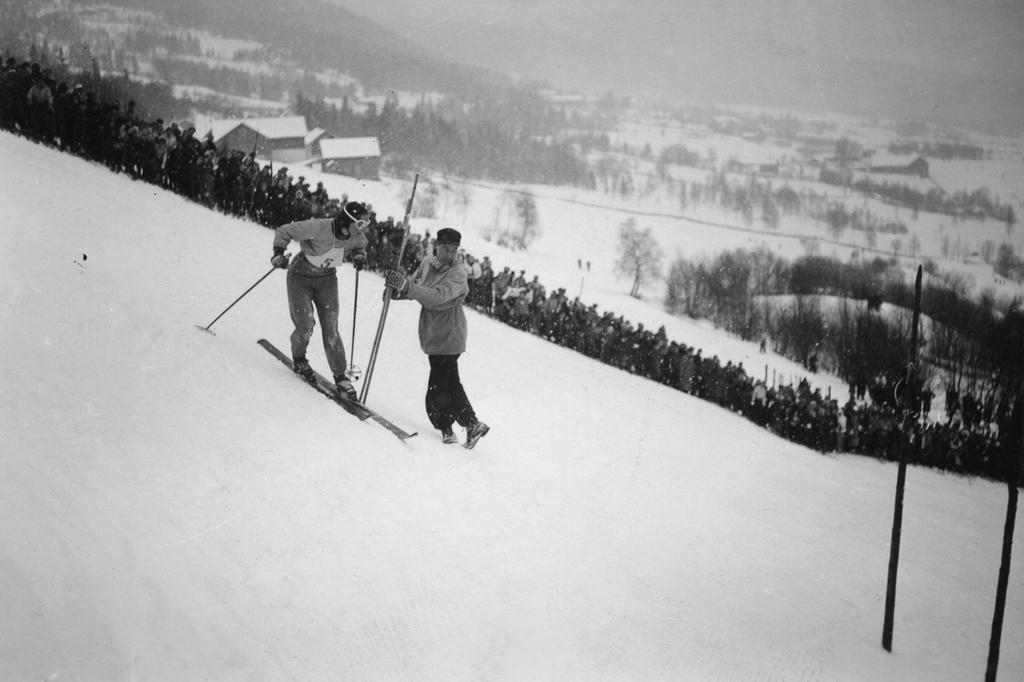Describe this image in one or two sentences. This picture is clicked outside the city. In the foreground we can see there is a lot of snow. In the center there are two persons seems to be skiing on the ski-board. In the background we can see the trees, sky, houses and the snow. On the right we can see the two poles. 